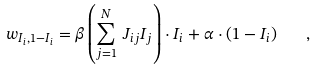Convert formula to latex. <formula><loc_0><loc_0><loc_500><loc_500>w _ { I _ { i } , 1 - I _ { i } } = \beta \left ( \sum _ { j = 1 } ^ { N } \, J _ { i j } I _ { j } \right ) \cdot I _ { i } + \alpha \cdot ( 1 - I _ { i } ) \quad ,</formula> 